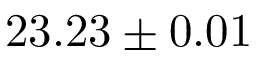<formula> <loc_0><loc_0><loc_500><loc_500>2 3 . 2 3 \pm 0 . 0 1</formula> 